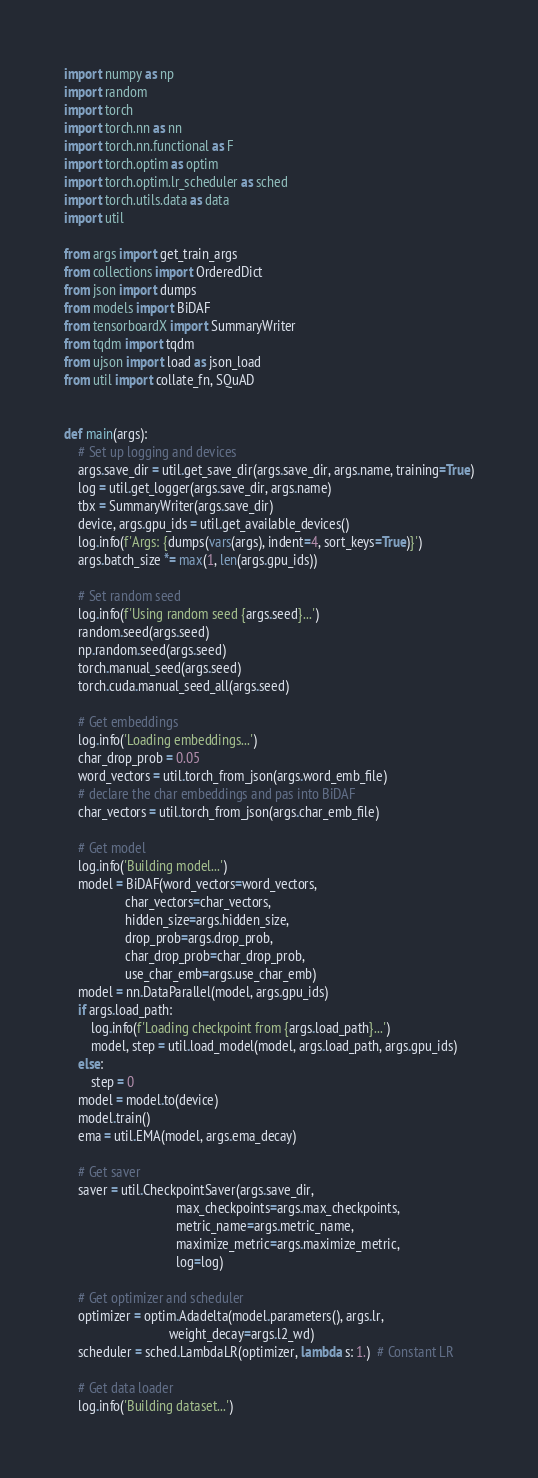<code> <loc_0><loc_0><loc_500><loc_500><_Python_>
import numpy as np
import random
import torch
import torch.nn as nn
import torch.nn.functional as F
import torch.optim as optim
import torch.optim.lr_scheduler as sched
import torch.utils.data as data
import util

from args import get_train_args
from collections import OrderedDict
from json import dumps
from models import BiDAF
from tensorboardX import SummaryWriter
from tqdm import tqdm
from ujson import load as json_load
from util import collate_fn, SQuAD


def main(args):
    # Set up logging and devices
    args.save_dir = util.get_save_dir(args.save_dir, args.name, training=True)
    log = util.get_logger(args.save_dir, args.name)
    tbx = SummaryWriter(args.save_dir)
    device, args.gpu_ids = util.get_available_devices()
    log.info(f'Args: {dumps(vars(args), indent=4, sort_keys=True)}')
    args.batch_size *= max(1, len(args.gpu_ids))

    # Set random seed
    log.info(f'Using random seed {args.seed}...')
    random.seed(args.seed)
    np.random.seed(args.seed)
    torch.manual_seed(args.seed)
    torch.cuda.manual_seed_all(args.seed)

    # Get embeddings
    log.info('Loading embeddings...')
    char_drop_prob = 0.05
    word_vectors = util.torch_from_json(args.word_emb_file)
    # declare the char embeddings and pas into BiDAF
    char_vectors = util.torch_from_json(args.char_emb_file)

    # Get model
    log.info('Building model...')
    model = BiDAF(word_vectors=word_vectors,
                  char_vectors=char_vectors,
                  hidden_size=args.hidden_size,
                  drop_prob=args.drop_prob,
                  char_drop_prob=char_drop_prob,
                  use_char_emb=args.use_char_emb)
    model = nn.DataParallel(model, args.gpu_ids)
    if args.load_path:
        log.info(f'Loading checkpoint from {args.load_path}...')
        model, step = util.load_model(model, args.load_path, args.gpu_ids)
    else:
        step = 0
    model = model.to(device)
    model.train()
    ema = util.EMA(model, args.ema_decay)

    # Get saver
    saver = util.CheckpointSaver(args.save_dir,
                                 max_checkpoints=args.max_checkpoints,
                                 metric_name=args.metric_name,
                                 maximize_metric=args.maximize_metric,
                                 log=log)

    # Get optimizer and scheduler
    optimizer = optim.Adadelta(model.parameters(), args.lr,
                               weight_decay=args.l2_wd)
    scheduler = sched.LambdaLR(optimizer, lambda s: 1.)  # Constant LR

    # Get data loader
    log.info('Building dataset...')</code> 